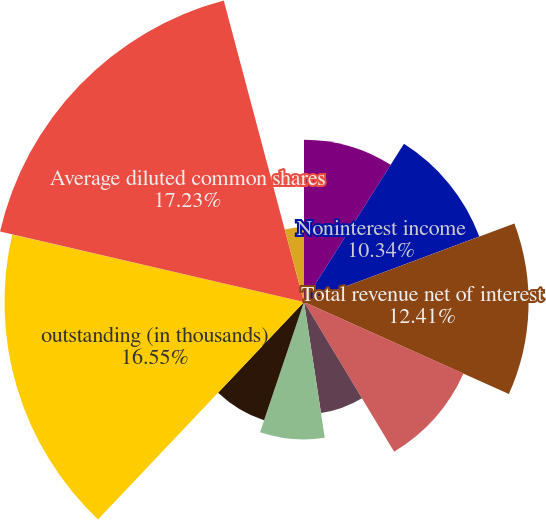<chart> <loc_0><loc_0><loc_500><loc_500><pie_chart><fcel>Net interest income<fcel>Noninterest income<fcel>Total revenue net of interest<fcel>Provision for credit losses<fcel>Merger and restructuring<fcel>Net income (loss) Net income<fcel>common shareholders Average<fcel>outstanding (in thousands)<fcel>Average diluted common shares<fcel>Total average equity to total<nl><fcel>8.97%<fcel>10.34%<fcel>12.41%<fcel>9.66%<fcel>6.21%<fcel>7.59%<fcel>6.9%<fcel>16.55%<fcel>17.24%<fcel>4.14%<nl></chart> 